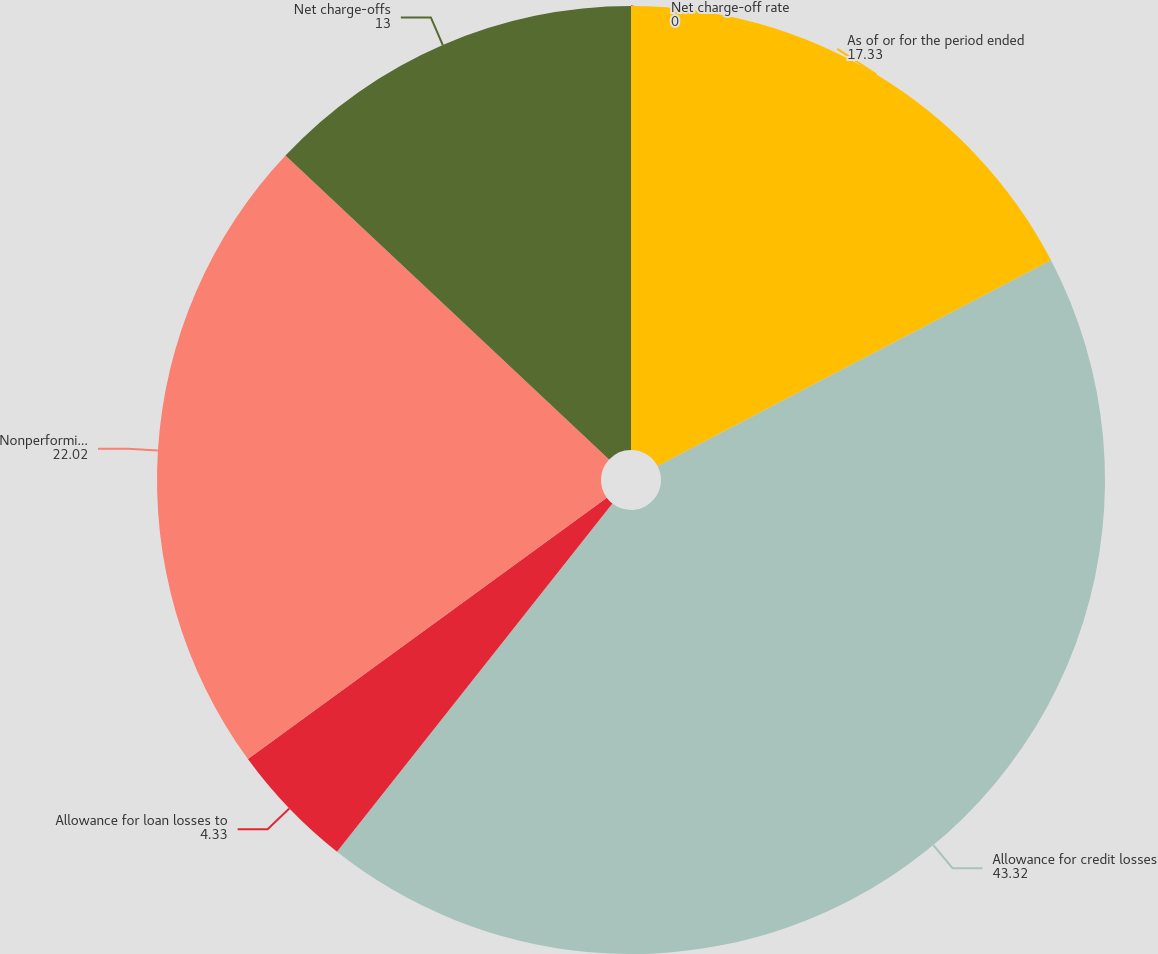Convert chart. <chart><loc_0><loc_0><loc_500><loc_500><pie_chart><fcel>As of or for the period ended<fcel>Allowance for credit losses<fcel>Allowance for loan losses to<fcel>Nonperforming assets<fcel>Net charge-offs<fcel>Net charge-off rate<nl><fcel>17.33%<fcel>43.32%<fcel>4.33%<fcel>22.02%<fcel>13.0%<fcel>0.0%<nl></chart> 